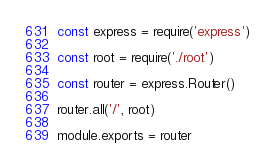Convert code to text. <code><loc_0><loc_0><loc_500><loc_500><_JavaScript_>const express = require('express')

const root = require('./root')

const router = express.Router()

router.all('/', root)

module.exports = router
</code> 